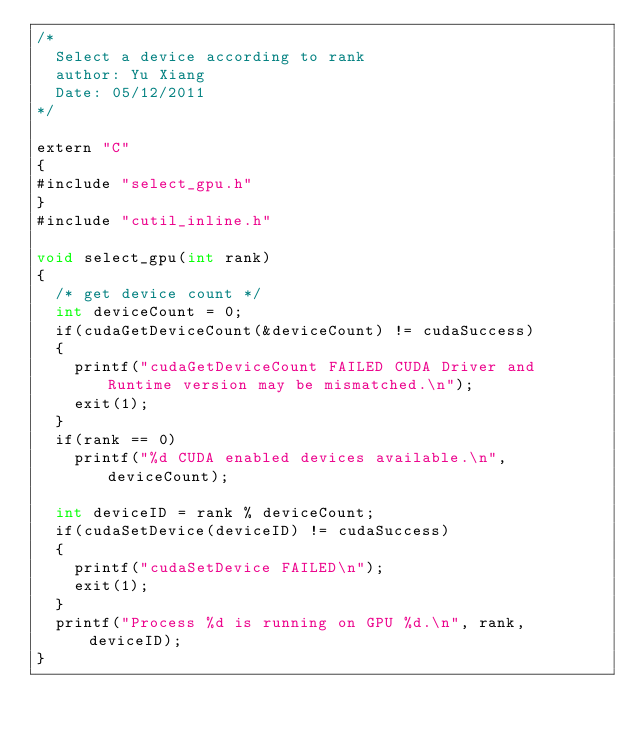Convert code to text. <code><loc_0><loc_0><loc_500><loc_500><_Cuda_>/*
  Select a device according to rank
  author: Yu Xiang
  Date: 05/12/2011
*/

extern "C"
{
#include "select_gpu.h"
}
#include "cutil_inline.h"

void select_gpu(int rank)
{
  /* get device count */
  int deviceCount = 0;
  if(cudaGetDeviceCount(&deviceCount) != cudaSuccess)
  {
    printf("cudaGetDeviceCount FAILED CUDA Driver and Runtime version may be mismatched.\n");
    exit(1);
  }
  if(rank == 0)
    printf("%d CUDA enabled devices available.\n", deviceCount);

  int deviceID = rank % deviceCount;
  if(cudaSetDevice(deviceID) != cudaSuccess)
  {
    printf("cudaSetDevice FAILED\n");
    exit(1);
  }
  printf("Process %d is running on GPU %d.\n", rank, deviceID);
}
</code> 